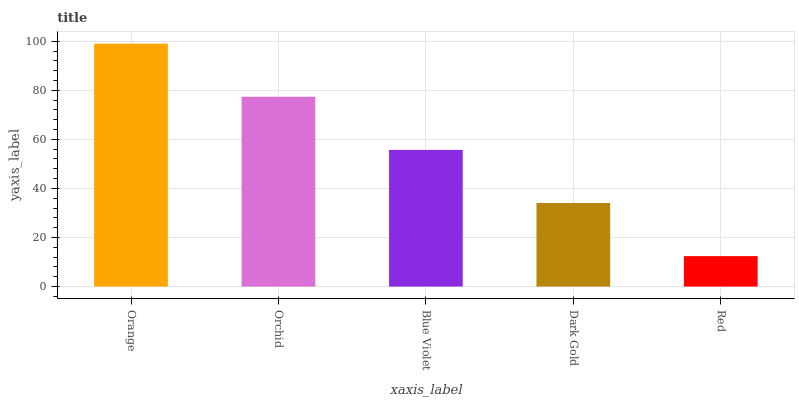Is Red the minimum?
Answer yes or no. Yes. Is Orange the maximum?
Answer yes or no. Yes. Is Orchid the minimum?
Answer yes or no. No. Is Orchid the maximum?
Answer yes or no. No. Is Orange greater than Orchid?
Answer yes or no. Yes. Is Orchid less than Orange?
Answer yes or no. Yes. Is Orchid greater than Orange?
Answer yes or no. No. Is Orange less than Orchid?
Answer yes or no. No. Is Blue Violet the high median?
Answer yes or no. Yes. Is Blue Violet the low median?
Answer yes or no. Yes. Is Orange the high median?
Answer yes or no. No. Is Dark Gold the low median?
Answer yes or no. No. 